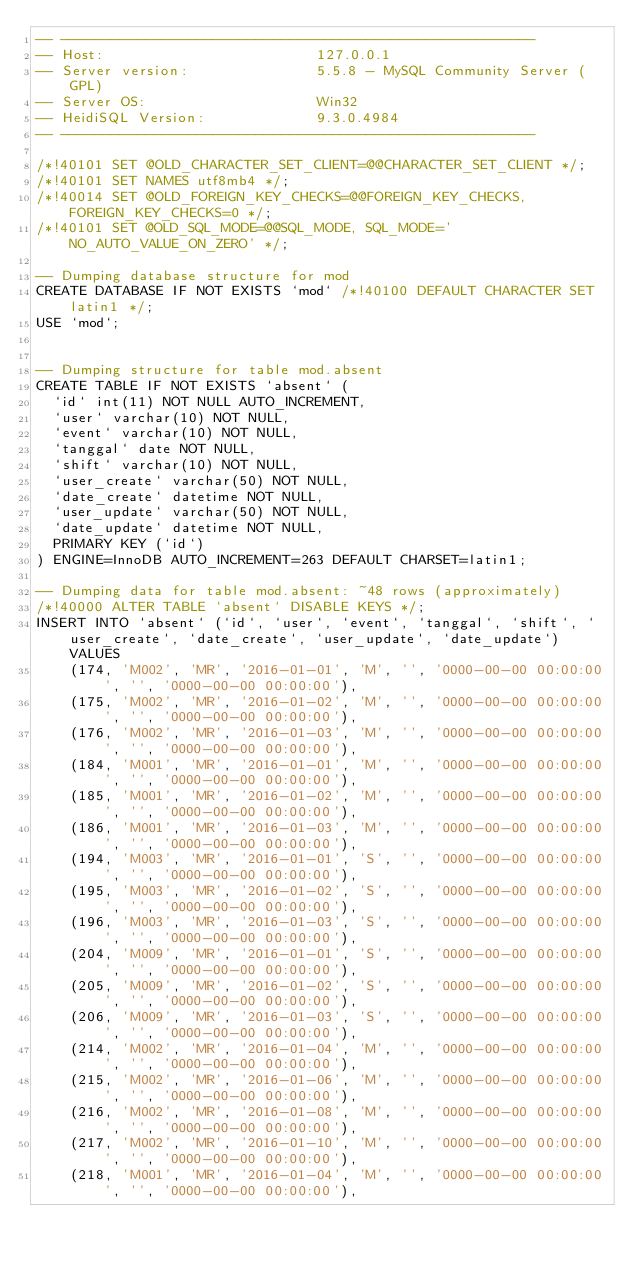Convert code to text. <code><loc_0><loc_0><loc_500><loc_500><_SQL_>-- --------------------------------------------------------
-- Host:                         127.0.0.1
-- Server version:               5.5.8 - MySQL Community Server (GPL)
-- Server OS:                    Win32
-- HeidiSQL Version:             9.3.0.4984
-- --------------------------------------------------------

/*!40101 SET @OLD_CHARACTER_SET_CLIENT=@@CHARACTER_SET_CLIENT */;
/*!40101 SET NAMES utf8mb4 */;
/*!40014 SET @OLD_FOREIGN_KEY_CHECKS=@@FOREIGN_KEY_CHECKS, FOREIGN_KEY_CHECKS=0 */;
/*!40101 SET @OLD_SQL_MODE=@@SQL_MODE, SQL_MODE='NO_AUTO_VALUE_ON_ZERO' */;

-- Dumping database structure for mod
CREATE DATABASE IF NOT EXISTS `mod` /*!40100 DEFAULT CHARACTER SET latin1 */;
USE `mod`;


-- Dumping structure for table mod.absent
CREATE TABLE IF NOT EXISTS `absent` (
  `id` int(11) NOT NULL AUTO_INCREMENT,
  `user` varchar(10) NOT NULL,
  `event` varchar(10) NOT NULL,
  `tanggal` date NOT NULL,
  `shift` varchar(10) NOT NULL,
  `user_create` varchar(50) NOT NULL,
  `date_create` datetime NOT NULL,
  `user_update` varchar(50) NOT NULL,
  `date_update` datetime NOT NULL,
  PRIMARY KEY (`id`)
) ENGINE=InnoDB AUTO_INCREMENT=263 DEFAULT CHARSET=latin1;

-- Dumping data for table mod.absent: ~48 rows (approximately)
/*!40000 ALTER TABLE `absent` DISABLE KEYS */;
INSERT INTO `absent` (`id`, `user`, `event`, `tanggal`, `shift`, `user_create`, `date_create`, `user_update`, `date_update`) VALUES
	(174, 'M002', 'MR', '2016-01-01', 'M', '', '0000-00-00 00:00:00', '', '0000-00-00 00:00:00'),
	(175, 'M002', 'MR', '2016-01-02', 'M', '', '0000-00-00 00:00:00', '', '0000-00-00 00:00:00'),
	(176, 'M002', 'MR', '2016-01-03', 'M', '', '0000-00-00 00:00:00', '', '0000-00-00 00:00:00'),
	(184, 'M001', 'MR', '2016-01-01', 'M', '', '0000-00-00 00:00:00', '', '0000-00-00 00:00:00'),
	(185, 'M001', 'MR', '2016-01-02', 'M', '', '0000-00-00 00:00:00', '', '0000-00-00 00:00:00'),
	(186, 'M001', 'MR', '2016-01-03', 'M', '', '0000-00-00 00:00:00', '', '0000-00-00 00:00:00'),
	(194, 'M003', 'MR', '2016-01-01', 'S', '', '0000-00-00 00:00:00', '', '0000-00-00 00:00:00'),
	(195, 'M003', 'MR', '2016-01-02', 'S', '', '0000-00-00 00:00:00', '', '0000-00-00 00:00:00'),
	(196, 'M003', 'MR', '2016-01-03', 'S', '', '0000-00-00 00:00:00', '', '0000-00-00 00:00:00'),
	(204, 'M009', 'MR', '2016-01-01', 'S', '', '0000-00-00 00:00:00', '', '0000-00-00 00:00:00'),
	(205, 'M009', 'MR', '2016-01-02', 'S', '', '0000-00-00 00:00:00', '', '0000-00-00 00:00:00'),
	(206, 'M009', 'MR', '2016-01-03', 'S', '', '0000-00-00 00:00:00', '', '0000-00-00 00:00:00'),
	(214, 'M002', 'MR', '2016-01-04', 'M', '', '0000-00-00 00:00:00', '', '0000-00-00 00:00:00'),
	(215, 'M002', 'MR', '2016-01-06', 'M', '', '0000-00-00 00:00:00', '', '0000-00-00 00:00:00'),
	(216, 'M002', 'MR', '2016-01-08', 'M', '', '0000-00-00 00:00:00', '', '0000-00-00 00:00:00'),
	(217, 'M002', 'MR', '2016-01-10', 'M', '', '0000-00-00 00:00:00', '', '0000-00-00 00:00:00'),
	(218, 'M001', 'MR', '2016-01-04', 'M', '', '0000-00-00 00:00:00', '', '0000-00-00 00:00:00'),</code> 